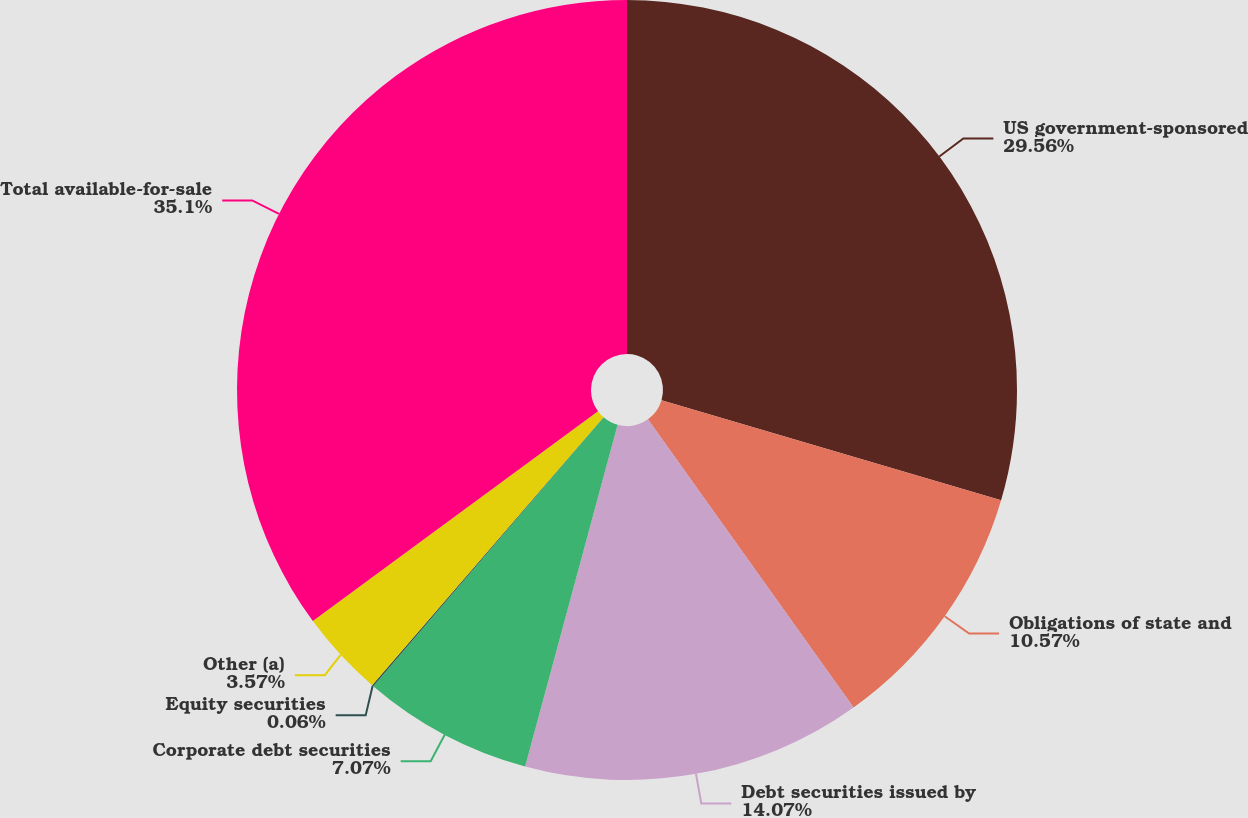Convert chart. <chart><loc_0><loc_0><loc_500><loc_500><pie_chart><fcel>US government-sponsored<fcel>Obligations of state and<fcel>Debt securities issued by<fcel>Corporate debt securities<fcel>Equity securities<fcel>Other (a)<fcel>Total available-for-sale<nl><fcel>29.56%<fcel>10.57%<fcel>14.07%<fcel>7.07%<fcel>0.06%<fcel>3.57%<fcel>35.09%<nl></chart> 